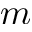Convert formula to latex. <formula><loc_0><loc_0><loc_500><loc_500>m</formula> 